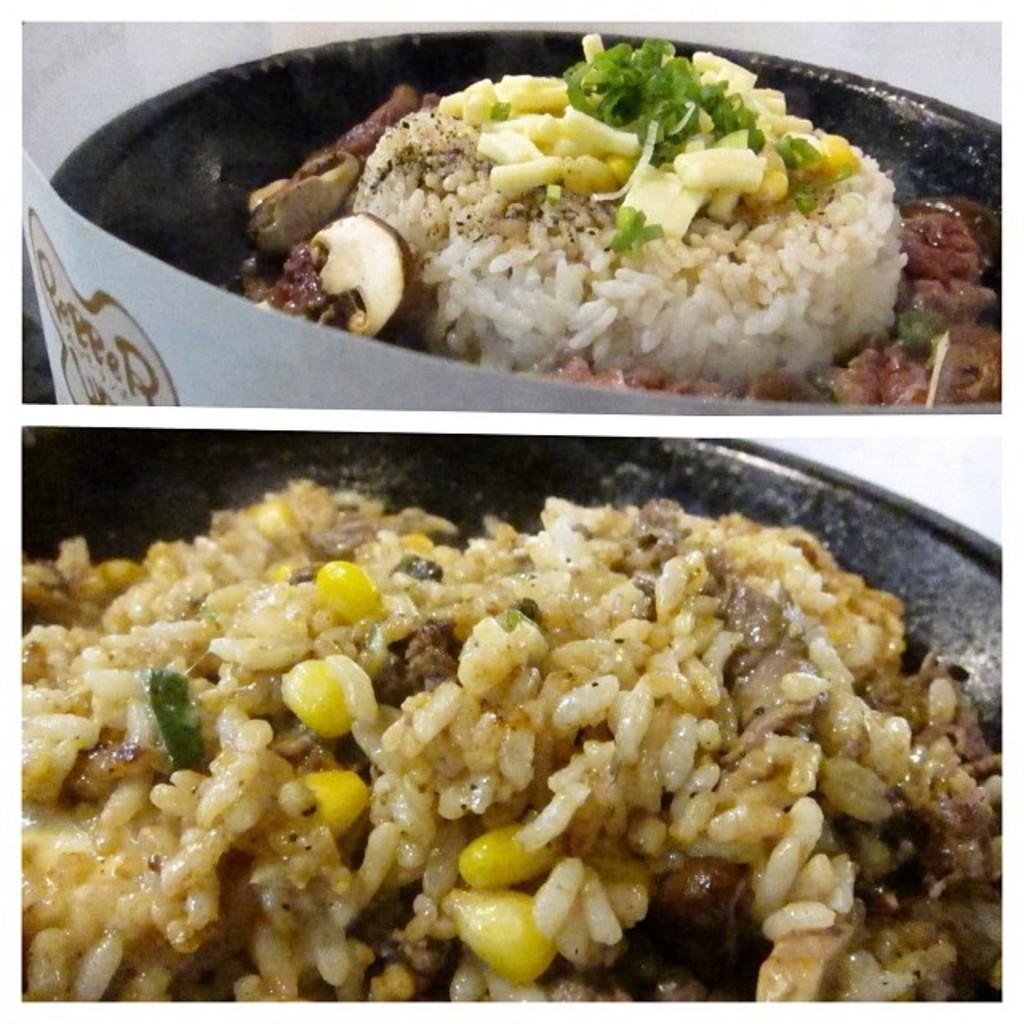What type of food can be seen in the image? The image contains food, including rice and corn. Can you describe the specific ingredients in the food? The food includes rice and corn. Where is the toothbrush stored in the image? There is no toothbrush present in the image. What type of drink is being served in the image? The provided facts do not mention any drinks in the image, so it cannot be determined from the image. 